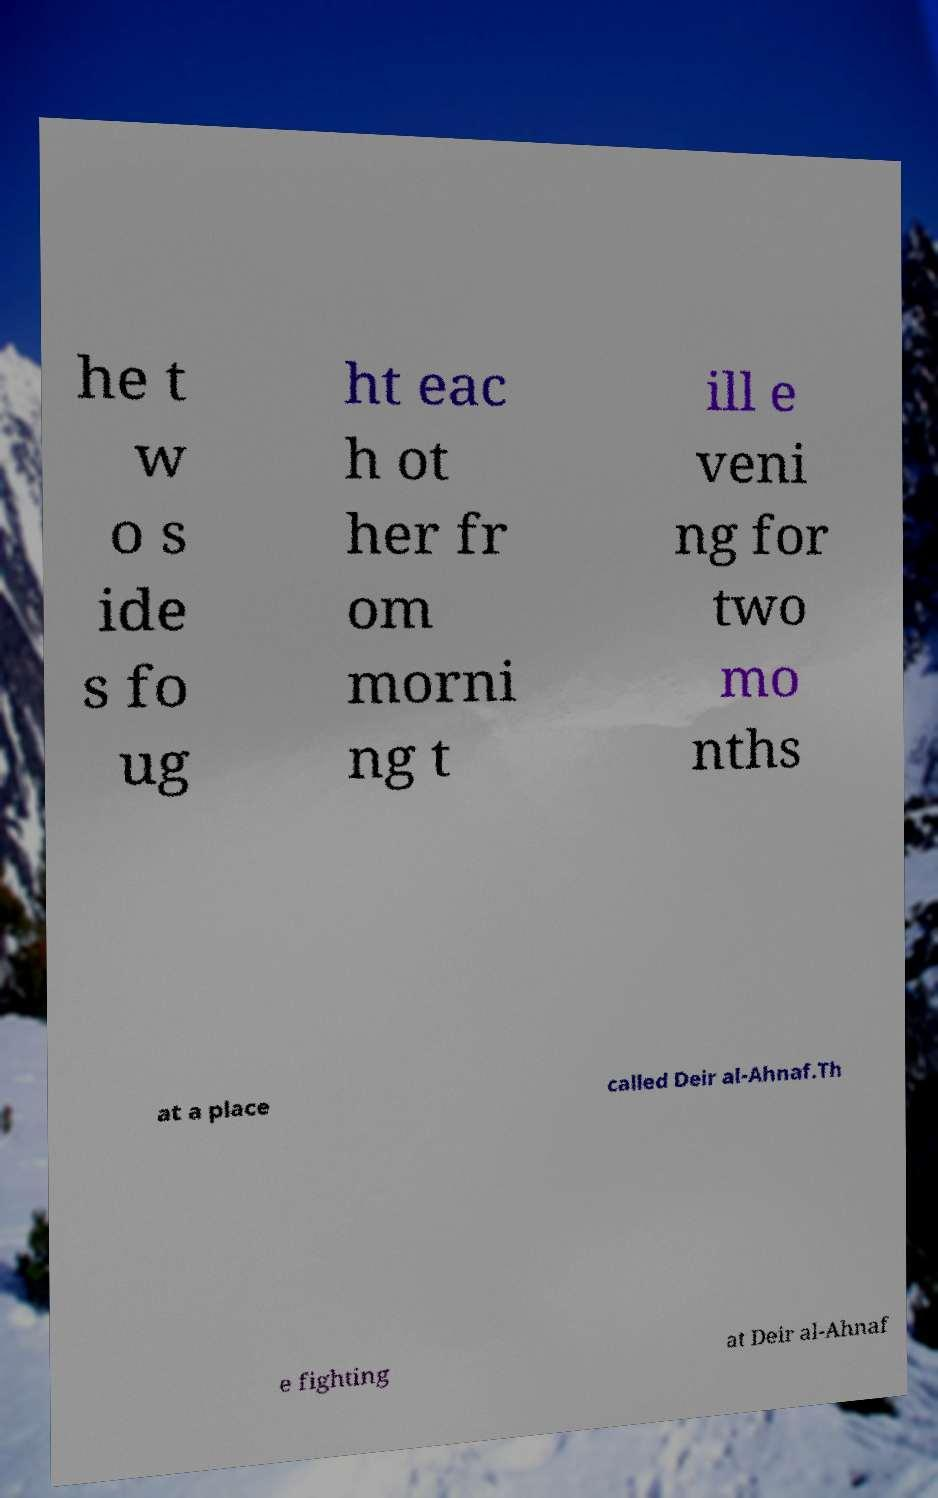Could you extract and type out the text from this image? he t w o s ide s fo ug ht eac h ot her fr om morni ng t ill e veni ng for two mo nths at a place called Deir al-Ahnaf.Th e fighting at Deir al-Ahnaf 